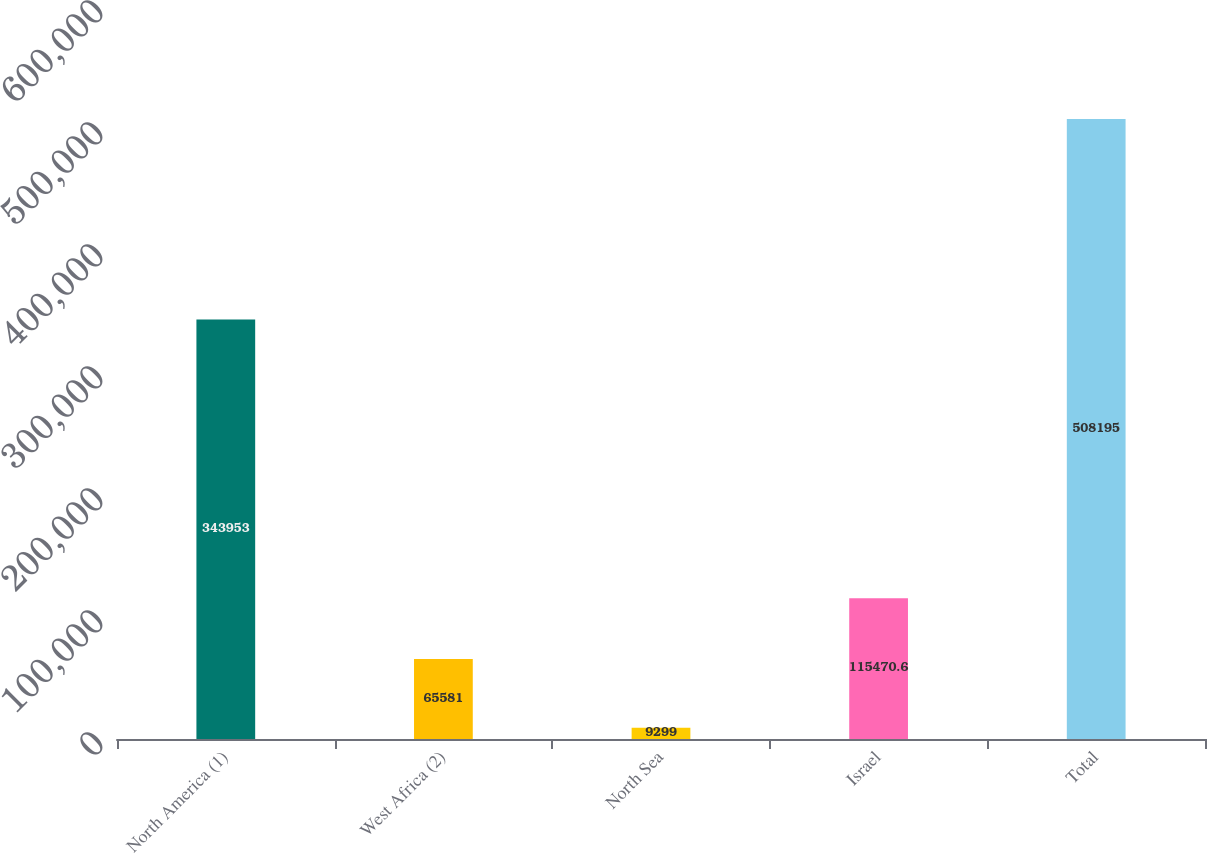<chart> <loc_0><loc_0><loc_500><loc_500><bar_chart><fcel>North America (1)<fcel>West Africa (2)<fcel>North Sea<fcel>Israel<fcel>Total<nl><fcel>343953<fcel>65581<fcel>9299<fcel>115471<fcel>508195<nl></chart> 